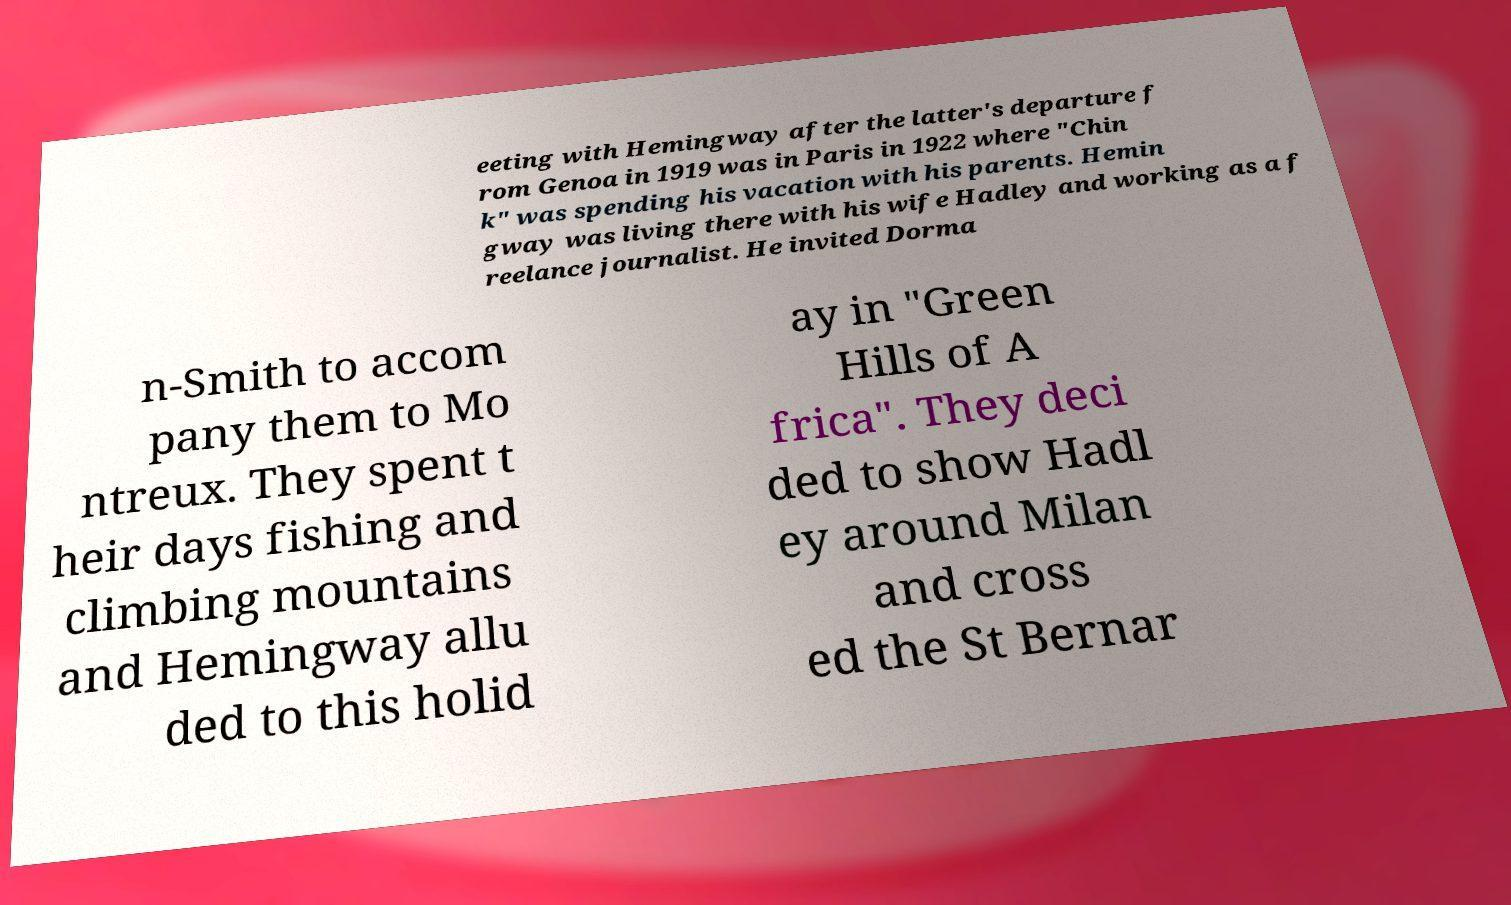Can you accurately transcribe the text from the provided image for me? eeting with Hemingway after the latter's departure f rom Genoa in 1919 was in Paris in 1922 where "Chin k" was spending his vacation with his parents. Hemin gway was living there with his wife Hadley and working as a f reelance journalist. He invited Dorma n-Smith to accom pany them to Mo ntreux. They spent t heir days fishing and climbing mountains and Hemingway allu ded to this holid ay in "Green Hills of A frica". They deci ded to show Hadl ey around Milan and cross ed the St Bernar 